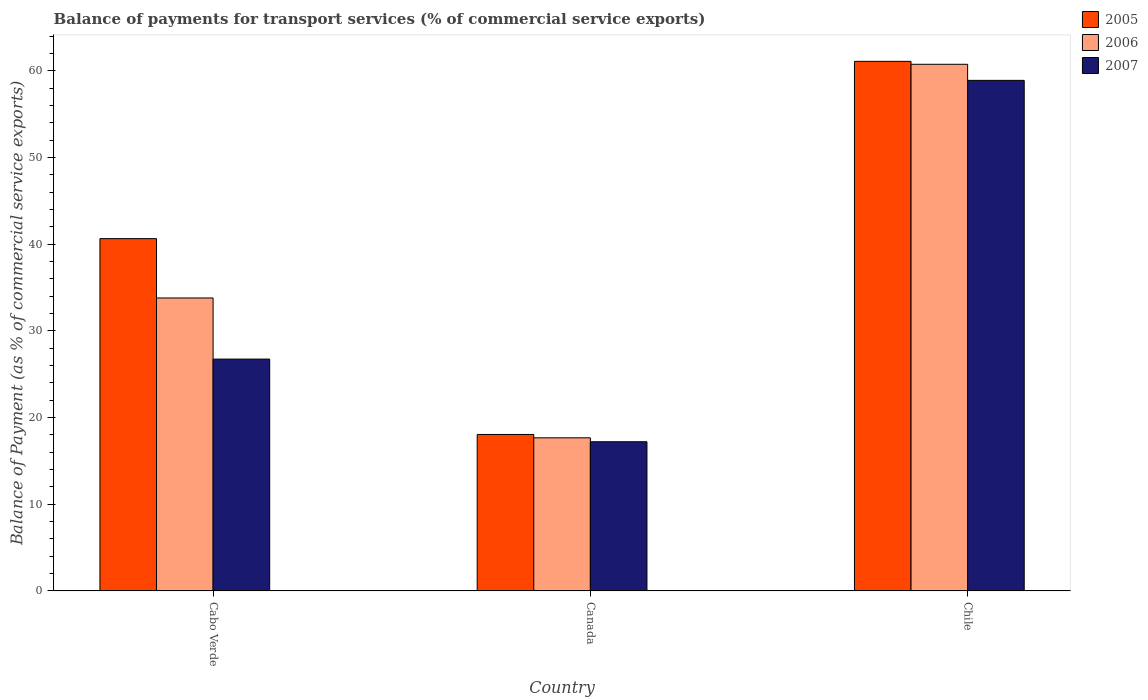How many groups of bars are there?
Give a very brief answer. 3. Are the number of bars per tick equal to the number of legend labels?
Provide a short and direct response. Yes. Are the number of bars on each tick of the X-axis equal?
Offer a very short reply. Yes. How many bars are there on the 1st tick from the left?
Your answer should be very brief. 3. What is the label of the 3rd group of bars from the left?
Keep it short and to the point. Chile. What is the balance of payments for transport services in 2007 in Chile?
Offer a very short reply. 58.9. Across all countries, what is the maximum balance of payments for transport services in 2007?
Your response must be concise. 58.9. Across all countries, what is the minimum balance of payments for transport services in 2006?
Your answer should be very brief. 17.66. In which country was the balance of payments for transport services in 2007 maximum?
Your answer should be very brief. Chile. What is the total balance of payments for transport services in 2006 in the graph?
Ensure brevity in your answer.  112.21. What is the difference between the balance of payments for transport services in 2005 in Cabo Verde and that in Chile?
Your answer should be very brief. -20.45. What is the difference between the balance of payments for transport services in 2005 in Chile and the balance of payments for transport services in 2007 in Cabo Verde?
Give a very brief answer. 34.35. What is the average balance of payments for transport services in 2005 per country?
Provide a succinct answer. 39.93. What is the difference between the balance of payments for transport services of/in 2006 and balance of payments for transport services of/in 2007 in Canada?
Provide a succinct answer. 0.45. What is the ratio of the balance of payments for transport services in 2005 in Cabo Verde to that in Chile?
Keep it short and to the point. 0.67. Is the balance of payments for transport services in 2005 in Cabo Verde less than that in Chile?
Give a very brief answer. Yes. Is the difference between the balance of payments for transport services in 2006 in Canada and Chile greater than the difference between the balance of payments for transport services in 2007 in Canada and Chile?
Provide a succinct answer. No. What is the difference between the highest and the second highest balance of payments for transport services in 2005?
Your answer should be very brief. 22.59. What is the difference between the highest and the lowest balance of payments for transport services in 2005?
Your answer should be very brief. 43.04. In how many countries, is the balance of payments for transport services in 2007 greater than the average balance of payments for transport services in 2007 taken over all countries?
Your answer should be very brief. 1. Is the sum of the balance of payments for transport services in 2005 in Cabo Verde and Canada greater than the maximum balance of payments for transport services in 2006 across all countries?
Ensure brevity in your answer.  No. Are all the bars in the graph horizontal?
Offer a very short reply. No. How many countries are there in the graph?
Offer a very short reply. 3. Does the graph contain any zero values?
Offer a terse response. No. Does the graph contain grids?
Offer a terse response. No. Where does the legend appear in the graph?
Keep it short and to the point. Top right. How many legend labels are there?
Your response must be concise. 3. How are the legend labels stacked?
Give a very brief answer. Vertical. What is the title of the graph?
Your answer should be very brief. Balance of payments for transport services (% of commercial service exports). Does "1994" appear as one of the legend labels in the graph?
Offer a very short reply. No. What is the label or title of the Y-axis?
Your answer should be compact. Balance of Payment (as % of commercial service exports). What is the Balance of Payment (as % of commercial service exports) of 2005 in Cabo Verde?
Give a very brief answer. 40.64. What is the Balance of Payment (as % of commercial service exports) of 2006 in Cabo Verde?
Offer a terse response. 33.79. What is the Balance of Payment (as % of commercial service exports) in 2007 in Cabo Verde?
Keep it short and to the point. 26.75. What is the Balance of Payment (as % of commercial service exports) in 2005 in Canada?
Make the answer very short. 18.05. What is the Balance of Payment (as % of commercial service exports) in 2006 in Canada?
Give a very brief answer. 17.66. What is the Balance of Payment (as % of commercial service exports) of 2007 in Canada?
Provide a short and direct response. 17.21. What is the Balance of Payment (as % of commercial service exports) in 2005 in Chile?
Give a very brief answer. 61.09. What is the Balance of Payment (as % of commercial service exports) in 2006 in Chile?
Your response must be concise. 60.75. What is the Balance of Payment (as % of commercial service exports) of 2007 in Chile?
Offer a very short reply. 58.9. Across all countries, what is the maximum Balance of Payment (as % of commercial service exports) in 2005?
Provide a short and direct response. 61.09. Across all countries, what is the maximum Balance of Payment (as % of commercial service exports) in 2006?
Keep it short and to the point. 60.75. Across all countries, what is the maximum Balance of Payment (as % of commercial service exports) in 2007?
Your response must be concise. 58.9. Across all countries, what is the minimum Balance of Payment (as % of commercial service exports) of 2005?
Keep it short and to the point. 18.05. Across all countries, what is the minimum Balance of Payment (as % of commercial service exports) of 2006?
Offer a terse response. 17.66. Across all countries, what is the minimum Balance of Payment (as % of commercial service exports) in 2007?
Your response must be concise. 17.21. What is the total Balance of Payment (as % of commercial service exports) in 2005 in the graph?
Offer a terse response. 119.78. What is the total Balance of Payment (as % of commercial service exports) in 2006 in the graph?
Make the answer very short. 112.21. What is the total Balance of Payment (as % of commercial service exports) of 2007 in the graph?
Your answer should be compact. 102.85. What is the difference between the Balance of Payment (as % of commercial service exports) of 2005 in Cabo Verde and that in Canada?
Ensure brevity in your answer.  22.59. What is the difference between the Balance of Payment (as % of commercial service exports) of 2006 in Cabo Verde and that in Canada?
Give a very brief answer. 16.13. What is the difference between the Balance of Payment (as % of commercial service exports) of 2007 in Cabo Verde and that in Canada?
Offer a very short reply. 9.53. What is the difference between the Balance of Payment (as % of commercial service exports) in 2005 in Cabo Verde and that in Chile?
Your answer should be very brief. -20.45. What is the difference between the Balance of Payment (as % of commercial service exports) of 2006 in Cabo Verde and that in Chile?
Your response must be concise. -26.96. What is the difference between the Balance of Payment (as % of commercial service exports) of 2007 in Cabo Verde and that in Chile?
Keep it short and to the point. -32.15. What is the difference between the Balance of Payment (as % of commercial service exports) of 2005 in Canada and that in Chile?
Provide a short and direct response. -43.04. What is the difference between the Balance of Payment (as % of commercial service exports) of 2006 in Canada and that in Chile?
Your response must be concise. -43.09. What is the difference between the Balance of Payment (as % of commercial service exports) of 2007 in Canada and that in Chile?
Ensure brevity in your answer.  -41.69. What is the difference between the Balance of Payment (as % of commercial service exports) in 2005 in Cabo Verde and the Balance of Payment (as % of commercial service exports) in 2006 in Canada?
Offer a terse response. 22.98. What is the difference between the Balance of Payment (as % of commercial service exports) in 2005 in Cabo Verde and the Balance of Payment (as % of commercial service exports) in 2007 in Canada?
Your response must be concise. 23.43. What is the difference between the Balance of Payment (as % of commercial service exports) in 2006 in Cabo Verde and the Balance of Payment (as % of commercial service exports) in 2007 in Canada?
Your response must be concise. 16.58. What is the difference between the Balance of Payment (as % of commercial service exports) in 2005 in Cabo Verde and the Balance of Payment (as % of commercial service exports) in 2006 in Chile?
Offer a very short reply. -20.11. What is the difference between the Balance of Payment (as % of commercial service exports) of 2005 in Cabo Verde and the Balance of Payment (as % of commercial service exports) of 2007 in Chile?
Offer a terse response. -18.26. What is the difference between the Balance of Payment (as % of commercial service exports) in 2006 in Cabo Verde and the Balance of Payment (as % of commercial service exports) in 2007 in Chile?
Provide a short and direct response. -25.1. What is the difference between the Balance of Payment (as % of commercial service exports) in 2005 in Canada and the Balance of Payment (as % of commercial service exports) in 2006 in Chile?
Make the answer very short. -42.7. What is the difference between the Balance of Payment (as % of commercial service exports) in 2005 in Canada and the Balance of Payment (as % of commercial service exports) in 2007 in Chile?
Your answer should be compact. -40.85. What is the difference between the Balance of Payment (as % of commercial service exports) in 2006 in Canada and the Balance of Payment (as % of commercial service exports) in 2007 in Chile?
Offer a very short reply. -41.23. What is the average Balance of Payment (as % of commercial service exports) of 2005 per country?
Your response must be concise. 39.93. What is the average Balance of Payment (as % of commercial service exports) in 2006 per country?
Offer a terse response. 37.4. What is the average Balance of Payment (as % of commercial service exports) in 2007 per country?
Provide a succinct answer. 34.28. What is the difference between the Balance of Payment (as % of commercial service exports) of 2005 and Balance of Payment (as % of commercial service exports) of 2006 in Cabo Verde?
Make the answer very short. 6.85. What is the difference between the Balance of Payment (as % of commercial service exports) in 2005 and Balance of Payment (as % of commercial service exports) in 2007 in Cabo Verde?
Make the answer very short. 13.89. What is the difference between the Balance of Payment (as % of commercial service exports) in 2006 and Balance of Payment (as % of commercial service exports) in 2007 in Cabo Verde?
Your answer should be compact. 7.05. What is the difference between the Balance of Payment (as % of commercial service exports) in 2005 and Balance of Payment (as % of commercial service exports) in 2006 in Canada?
Provide a short and direct response. 0.39. What is the difference between the Balance of Payment (as % of commercial service exports) of 2005 and Balance of Payment (as % of commercial service exports) of 2007 in Canada?
Your response must be concise. 0.84. What is the difference between the Balance of Payment (as % of commercial service exports) in 2006 and Balance of Payment (as % of commercial service exports) in 2007 in Canada?
Offer a terse response. 0.45. What is the difference between the Balance of Payment (as % of commercial service exports) in 2005 and Balance of Payment (as % of commercial service exports) in 2006 in Chile?
Provide a short and direct response. 0.34. What is the difference between the Balance of Payment (as % of commercial service exports) in 2005 and Balance of Payment (as % of commercial service exports) in 2007 in Chile?
Provide a succinct answer. 2.19. What is the difference between the Balance of Payment (as % of commercial service exports) in 2006 and Balance of Payment (as % of commercial service exports) in 2007 in Chile?
Your answer should be very brief. 1.85. What is the ratio of the Balance of Payment (as % of commercial service exports) of 2005 in Cabo Verde to that in Canada?
Your response must be concise. 2.25. What is the ratio of the Balance of Payment (as % of commercial service exports) in 2006 in Cabo Verde to that in Canada?
Keep it short and to the point. 1.91. What is the ratio of the Balance of Payment (as % of commercial service exports) of 2007 in Cabo Verde to that in Canada?
Provide a short and direct response. 1.55. What is the ratio of the Balance of Payment (as % of commercial service exports) in 2005 in Cabo Verde to that in Chile?
Your answer should be very brief. 0.67. What is the ratio of the Balance of Payment (as % of commercial service exports) of 2006 in Cabo Verde to that in Chile?
Provide a short and direct response. 0.56. What is the ratio of the Balance of Payment (as % of commercial service exports) in 2007 in Cabo Verde to that in Chile?
Offer a terse response. 0.45. What is the ratio of the Balance of Payment (as % of commercial service exports) in 2005 in Canada to that in Chile?
Ensure brevity in your answer.  0.3. What is the ratio of the Balance of Payment (as % of commercial service exports) of 2006 in Canada to that in Chile?
Your answer should be very brief. 0.29. What is the ratio of the Balance of Payment (as % of commercial service exports) of 2007 in Canada to that in Chile?
Make the answer very short. 0.29. What is the difference between the highest and the second highest Balance of Payment (as % of commercial service exports) in 2005?
Ensure brevity in your answer.  20.45. What is the difference between the highest and the second highest Balance of Payment (as % of commercial service exports) of 2006?
Your response must be concise. 26.96. What is the difference between the highest and the second highest Balance of Payment (as % of commercial service exports) in 2007?
Your answer should be very brief. 32.15. What is the difference between the highest and the lowest Balance of Payment (as % of commercial service exports) of 2005?
Make the answer very short. 43.04. What is the difference between the highest and the lowest Balance of Payment (as % of commercial service exports) of 2006?
Provide a short and direct response. 43.09. What is the difference between the highest and the lowest Balance of Payment (as % of commercial service exports) of 2007?
Your answer should be very brief. 41.69. 